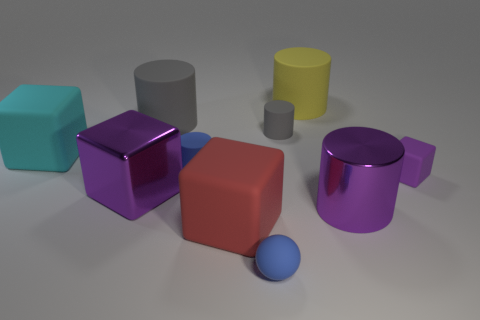What material is the tiny object that is the same color as the small sphere?
Your response must be concise. Rubber. What number of large cubes are the same color as the tiny matte cube?
Make the answer very short. 1. What number of other objects are the same size as the yellow cylinder?
Give a very brief answer. 5. Are there any tiny purple things that have the same material as the blue sphere?
Ensure brevity in your answer.  Yes. There is a gray object that is the same size as the blue cylinder; what is it made of?
Make the answer very short. Rubber. What color is the small cylinder on the left side of the small blue object that is in front of the purple thing that is to the left of the large red cube?
Ensure brevity in your answer.  Blue. There is a large rubber object that is in front of the large cyan cube; does it have the same shape as the blue thing behind the purple matte object?
Give a very brief answer. No. How many small brown metal objects are there?
Offer a terse response. 0. The rubber cylinder that is the same size as the yellow matte object is what color?
Your answer should be compact. Gray. Does the large purple thing that is on the right side of the small gray object have the same material as the cube behind the small purple block?
Ensure brevity in your answer.  No. 